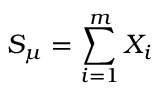Convert formula to latex. <formula><loc_0><loc_0><loc_500><loc_500>S _ { \mu } = \sum _ { i = 1 } ^ { m } X _ { i }</formula> 